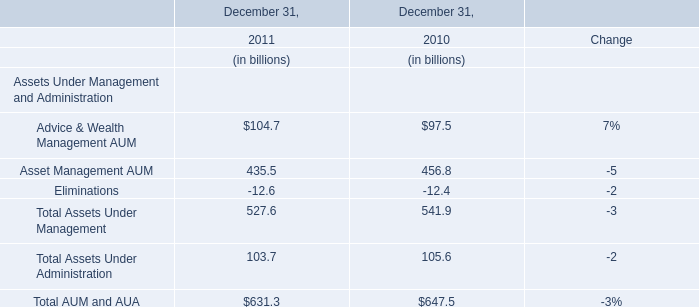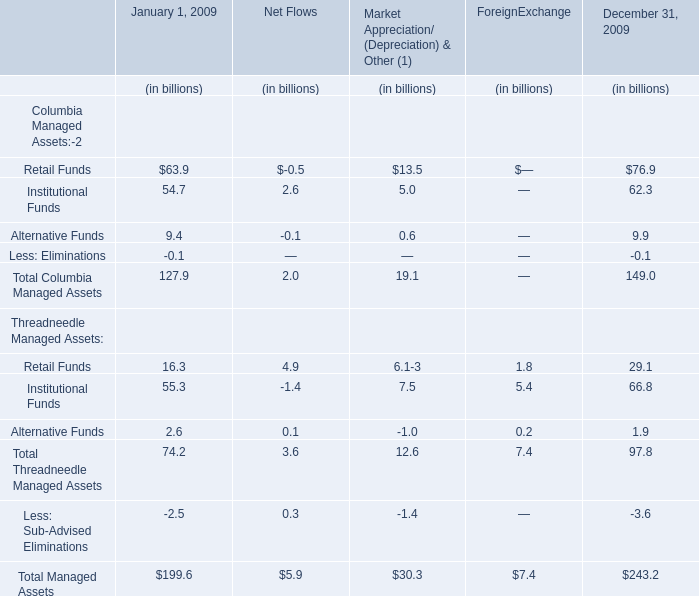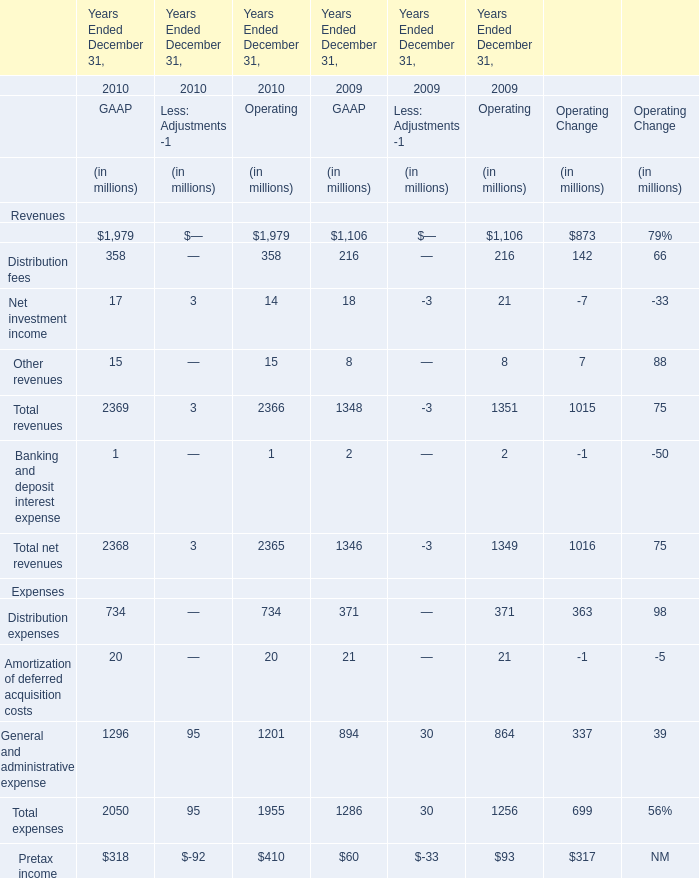What's the total amount of the expenses in the years where distribution expenses is greater than 700? (in million) 
Computations: ((734 + 20) + 1296)
Answer: 2050.0. 